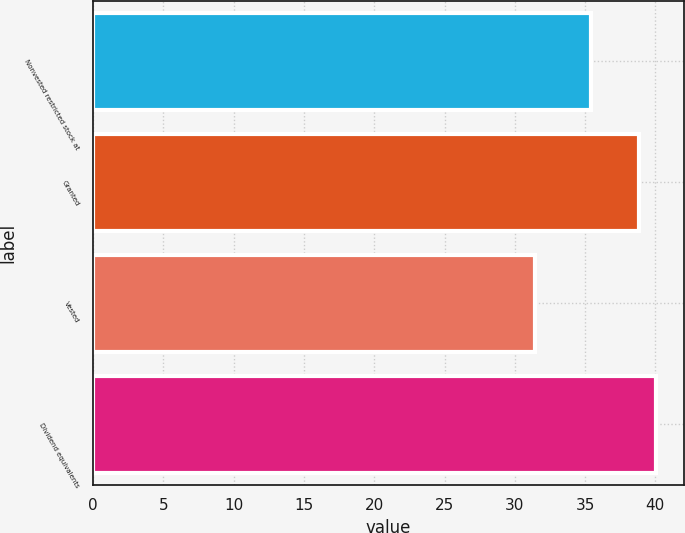<chart> <loc_0><loc_0><loc_500><loc_500><bar_chart><fcel>Nonvested restricted stock at<fcel>Granted<fcel>Vested<fcel>Dividend equivalents<nl><fcel>35.43<fcel>38.82<fcel>31.41<fcel>40.04<nl></chart> 